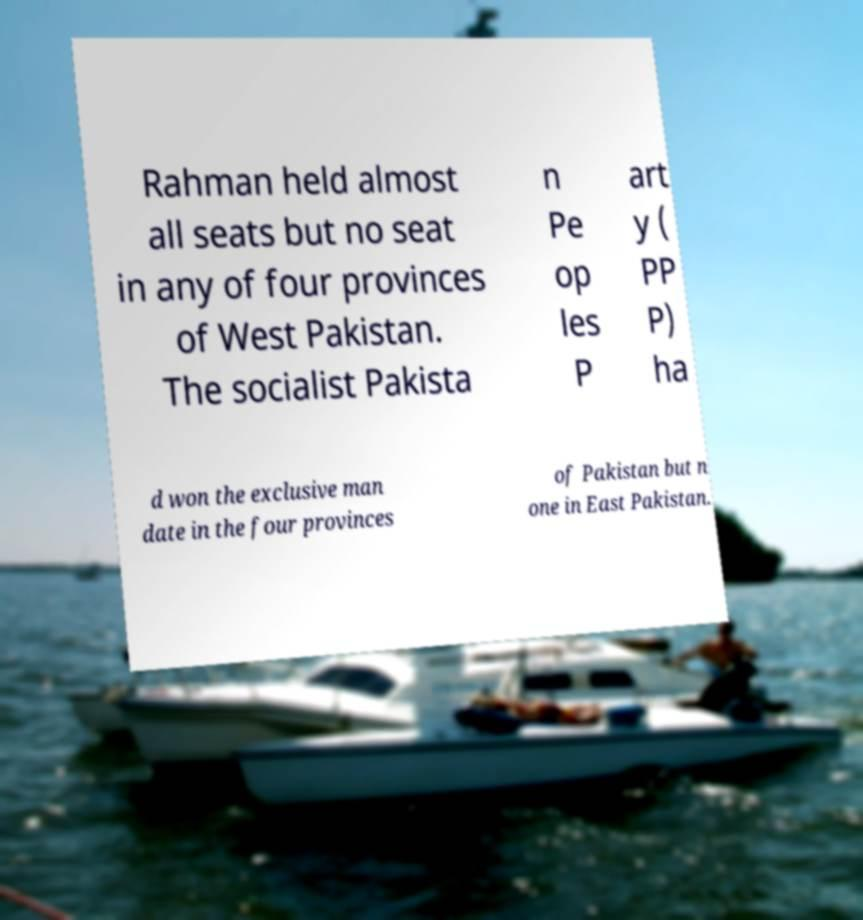For documentation purposes, I need the text within this image transcribed. Could you provide that? Rahman held almost all seats but no seat in any of four provinces of West Pakistan. The socialist Pakista n Pe op les P art y ( PP P) ha d won the exclusive man date in the four provinces of Pakistan but n one in East Pakistan. 